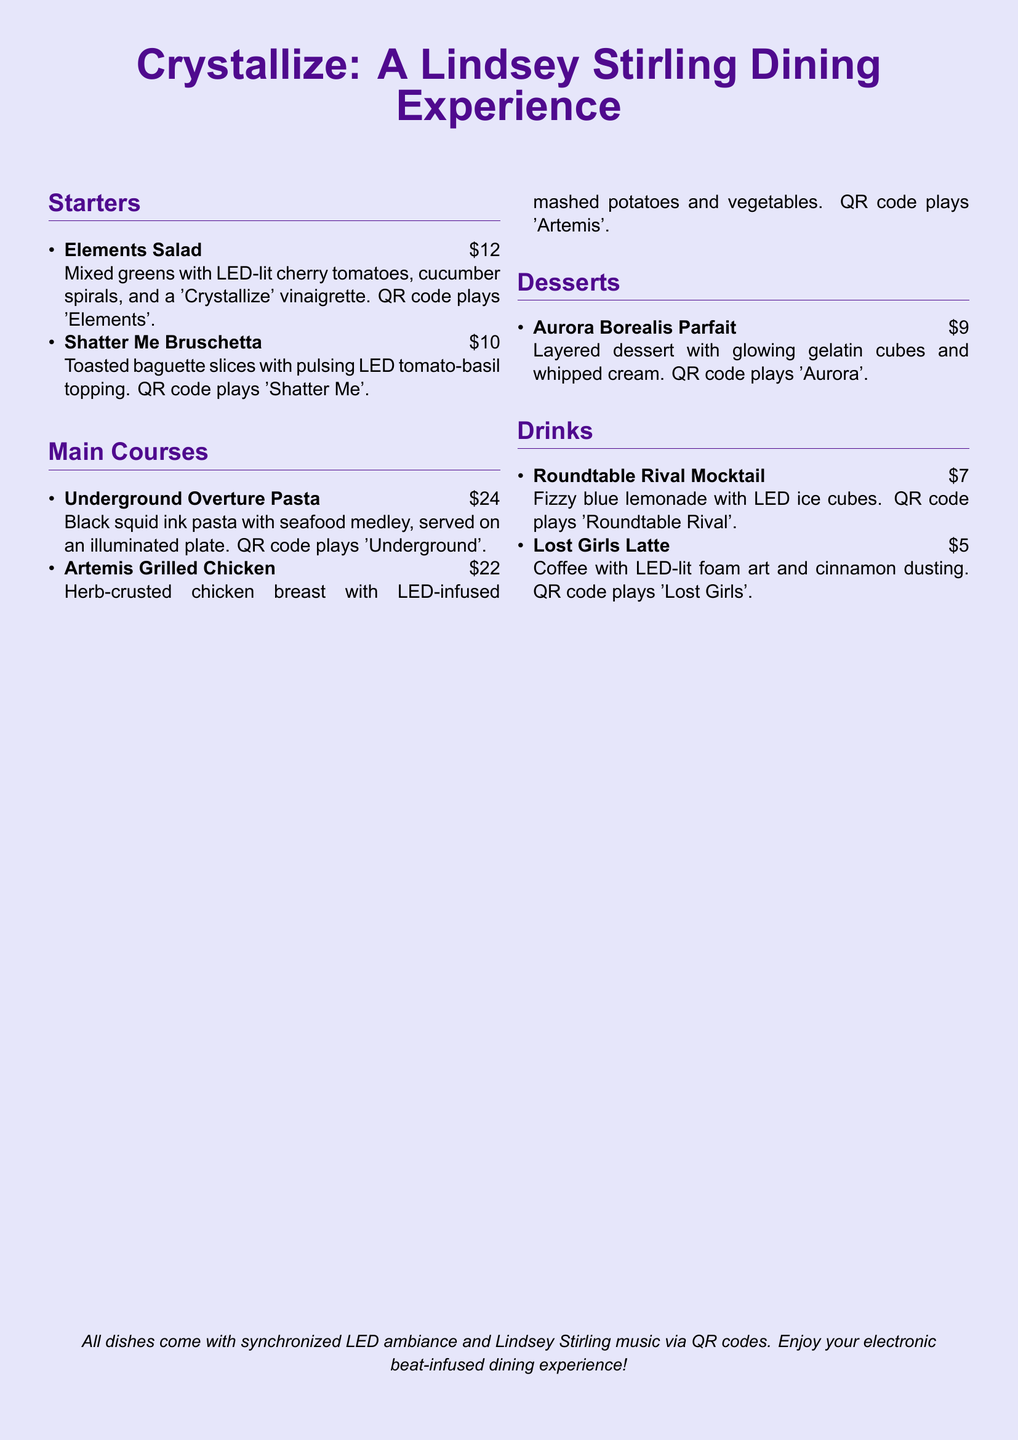what is the name of the dessert? The dessert is listed as the last menu item under the Desserts section.
Answer: Aurora Borealis Parfait how much does the Elements Salad cost? The cost of Elements Salad is specified right after the menu item name.
Answer: $12 which main course features seafood? The main courses section lists various items; this question refers to one identified by its main ingredient.
Answer: Underground Overture Pasta what QR code plays 'Lost Girls'? This question is about the specific drink associated with this music track in the menu.
Answer: Lost Girls Latte how many starters are listed? The document features a section that counts the number of items in the Starters category.
Answer: 2 which drink has LED ice cubes? This information pertains to a specific drink listed in the menu.
Answer: Roundtable Rival Mocktail what is served with the Artemis Grilled Chicken? This question asks for additional information about the main course's sides.
Answer: LED-infused mashed potatoes and vegetables which song is associated with the dessert? This question focuses on the musical element linked to the dessert item.
Answer: Aurora what color lighting accompanies the dining experience? The ambiance of the dining experience is described, giving insight into the thematic elements.
Answer: LED 